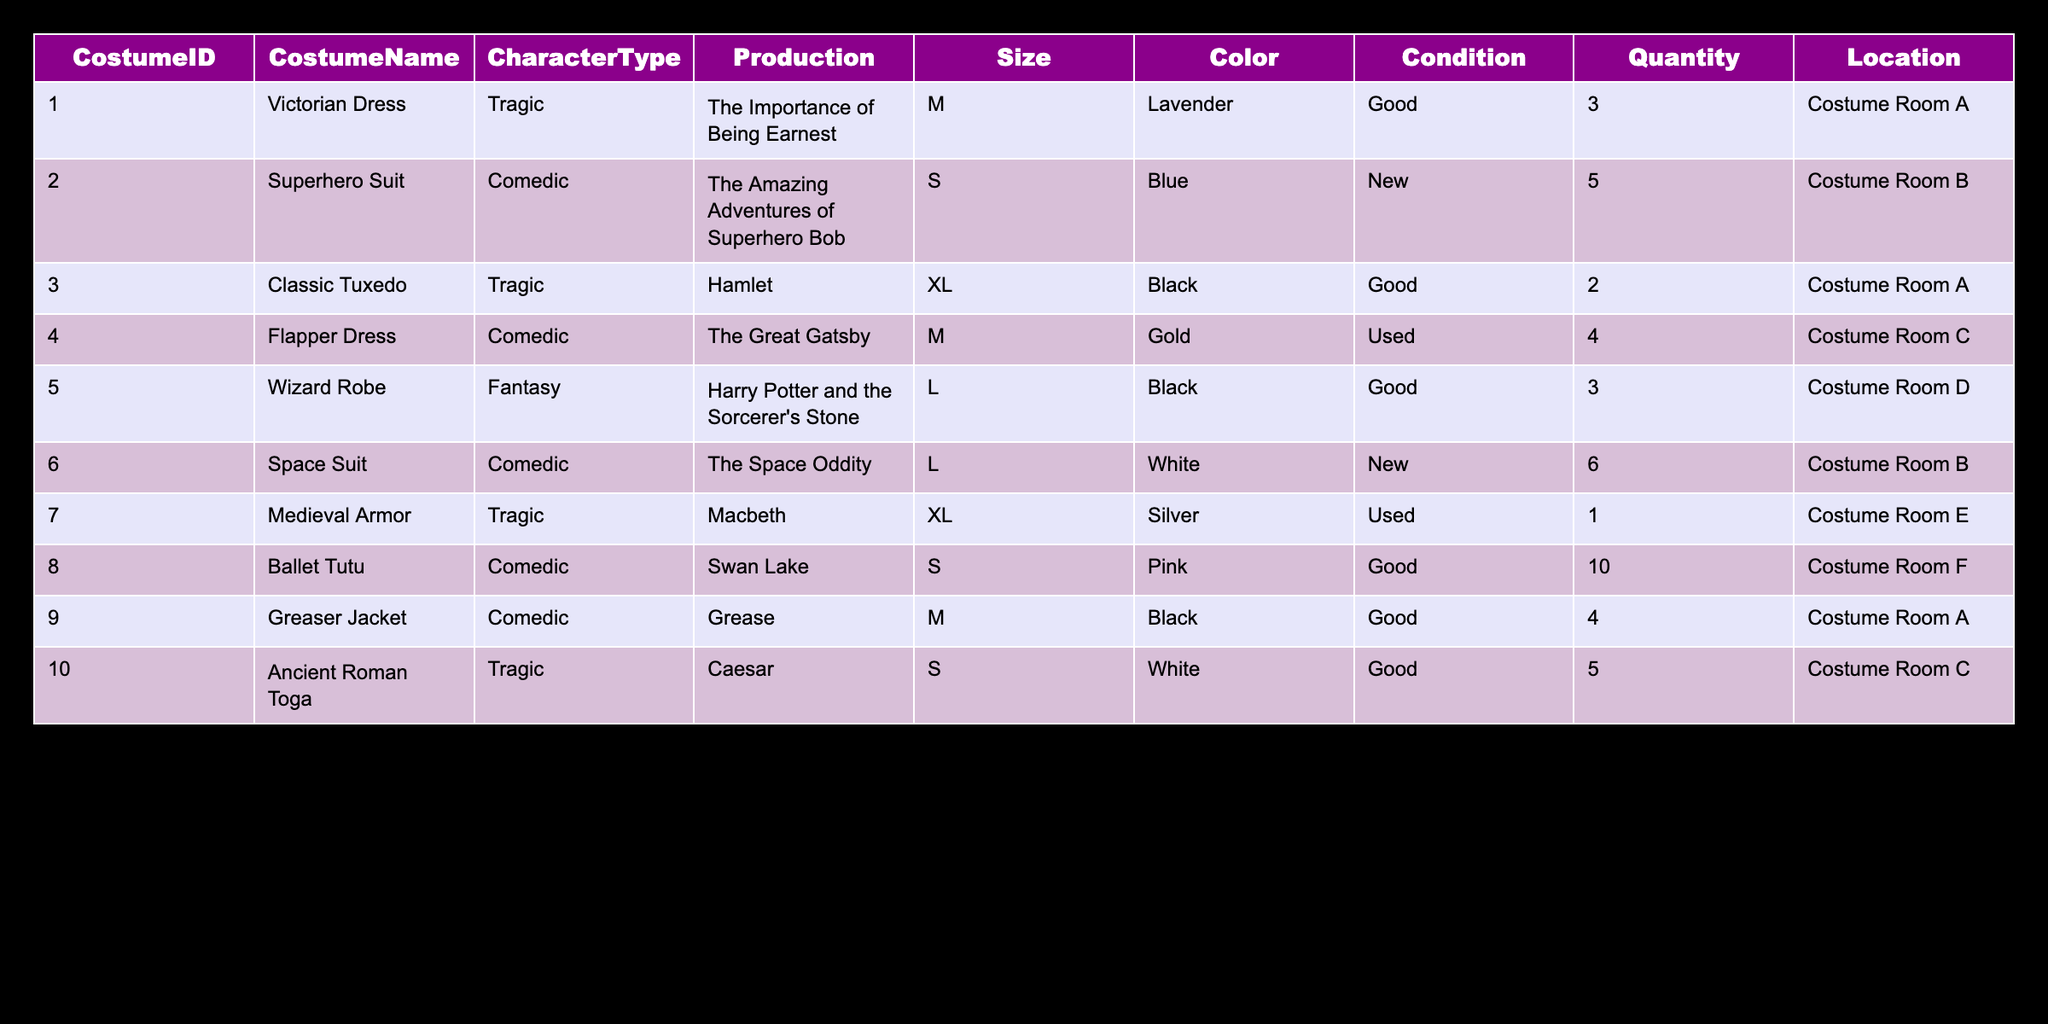What is the total quantity of Comedic costumes available? To find the total quantity of Comedic costumes, we look at all rows where CharacterType is "Comedic." The quantities are 5 (Superhero Suit) + 6 (Space Suit) + 10 (Ballet Tutu) + 4 (Greaser Jacket) = 25.
Answer: 25 Which costume is in the best condition? To determine which costume is in the best condition, we scan the Condition column for "New." The "Superhero Suit" and "Space Suit" are both new. Hence, either can be considered as they are both in the best condition.
Answer: Superhero Suit or Space Suit How many tragic costumes are larger than size M? The sizes larger than M are L and XL. The tragic costumes that fit these sizes are the "Classic Tuxedo" (XL) and "Medieval Armor" (XL). Therefore, the count of such costumes is 2.
Answer: 2 Is there a Flapper Dress available in the inventory? We check the CostumeName column to find "Flapper Dress." The dress is listed in the inventory, confirming its availability.
Answer: Yes What is the total number of Victorian Dresses and Ancient Roman Togas combined? We identify the quantities for both costumes: Victorian Dress has 3 and Ancient Roman Toga has 5. Adding these gives us 3 + 5 = 8.
Answer: 8 Are there any costumes in used condition? We check the Condition column for "Used." The "Flapper Dress" and "Medieval Armor" fall under this category. This confirms that there are costumes in used condition in the inventory.
Answer: Yes What is the color of the largest size costume available? The largest size available in the table is XL. The largest size costumes are "Classic Tuxedo" and "Medieval Armor." The colors for both are Black and Silver, respectively. The different colors should be noted since they are not the same.
Answer: Black and Silver Which costume has the highest quantity and how many are available? We review the Quantity column for all costumes. The "Ballet Tutu" has the highest quantity of 10. Thus, it is the costume with the highest availability.
Answer: 10 